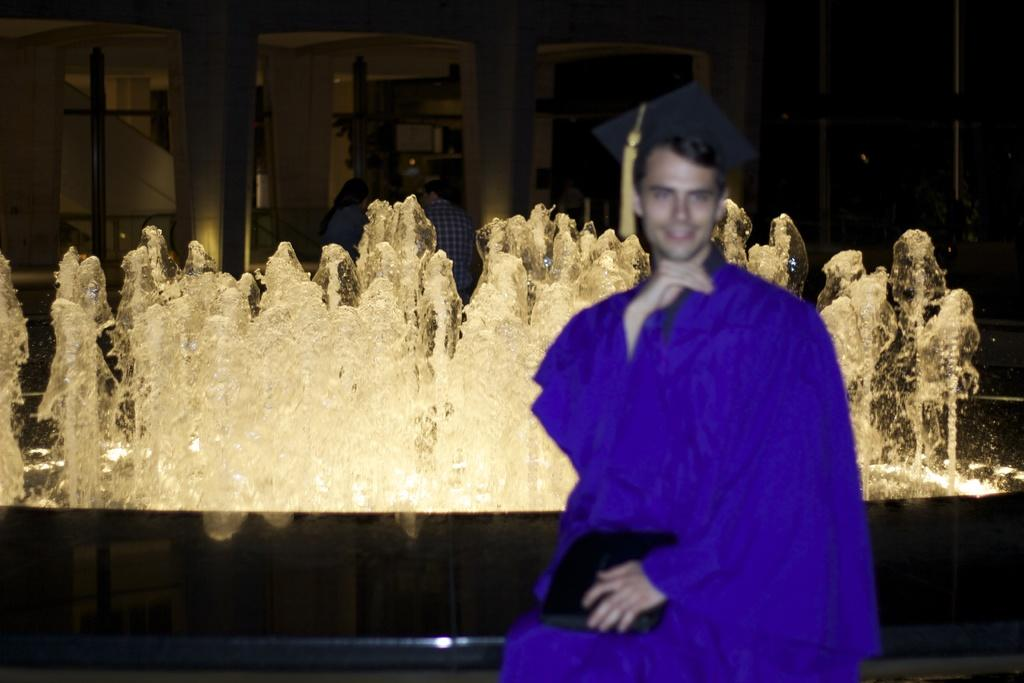What is the man in the image wearing? The man is wearing a graduation cap and gown. What is the man holding in the image? The man is holding an object. What can be seen in the background of the image? There is a fountain, people, and a building in the background of the image. What type of hill can be seen in the background of the image? There is no hill present in the image; the background features a fountain, people, and a building. What is the man using to attach his graduation cap to his head in the image? The man is not using glue to attach his graduation cap to his head in the image; he is wearing it properly. 